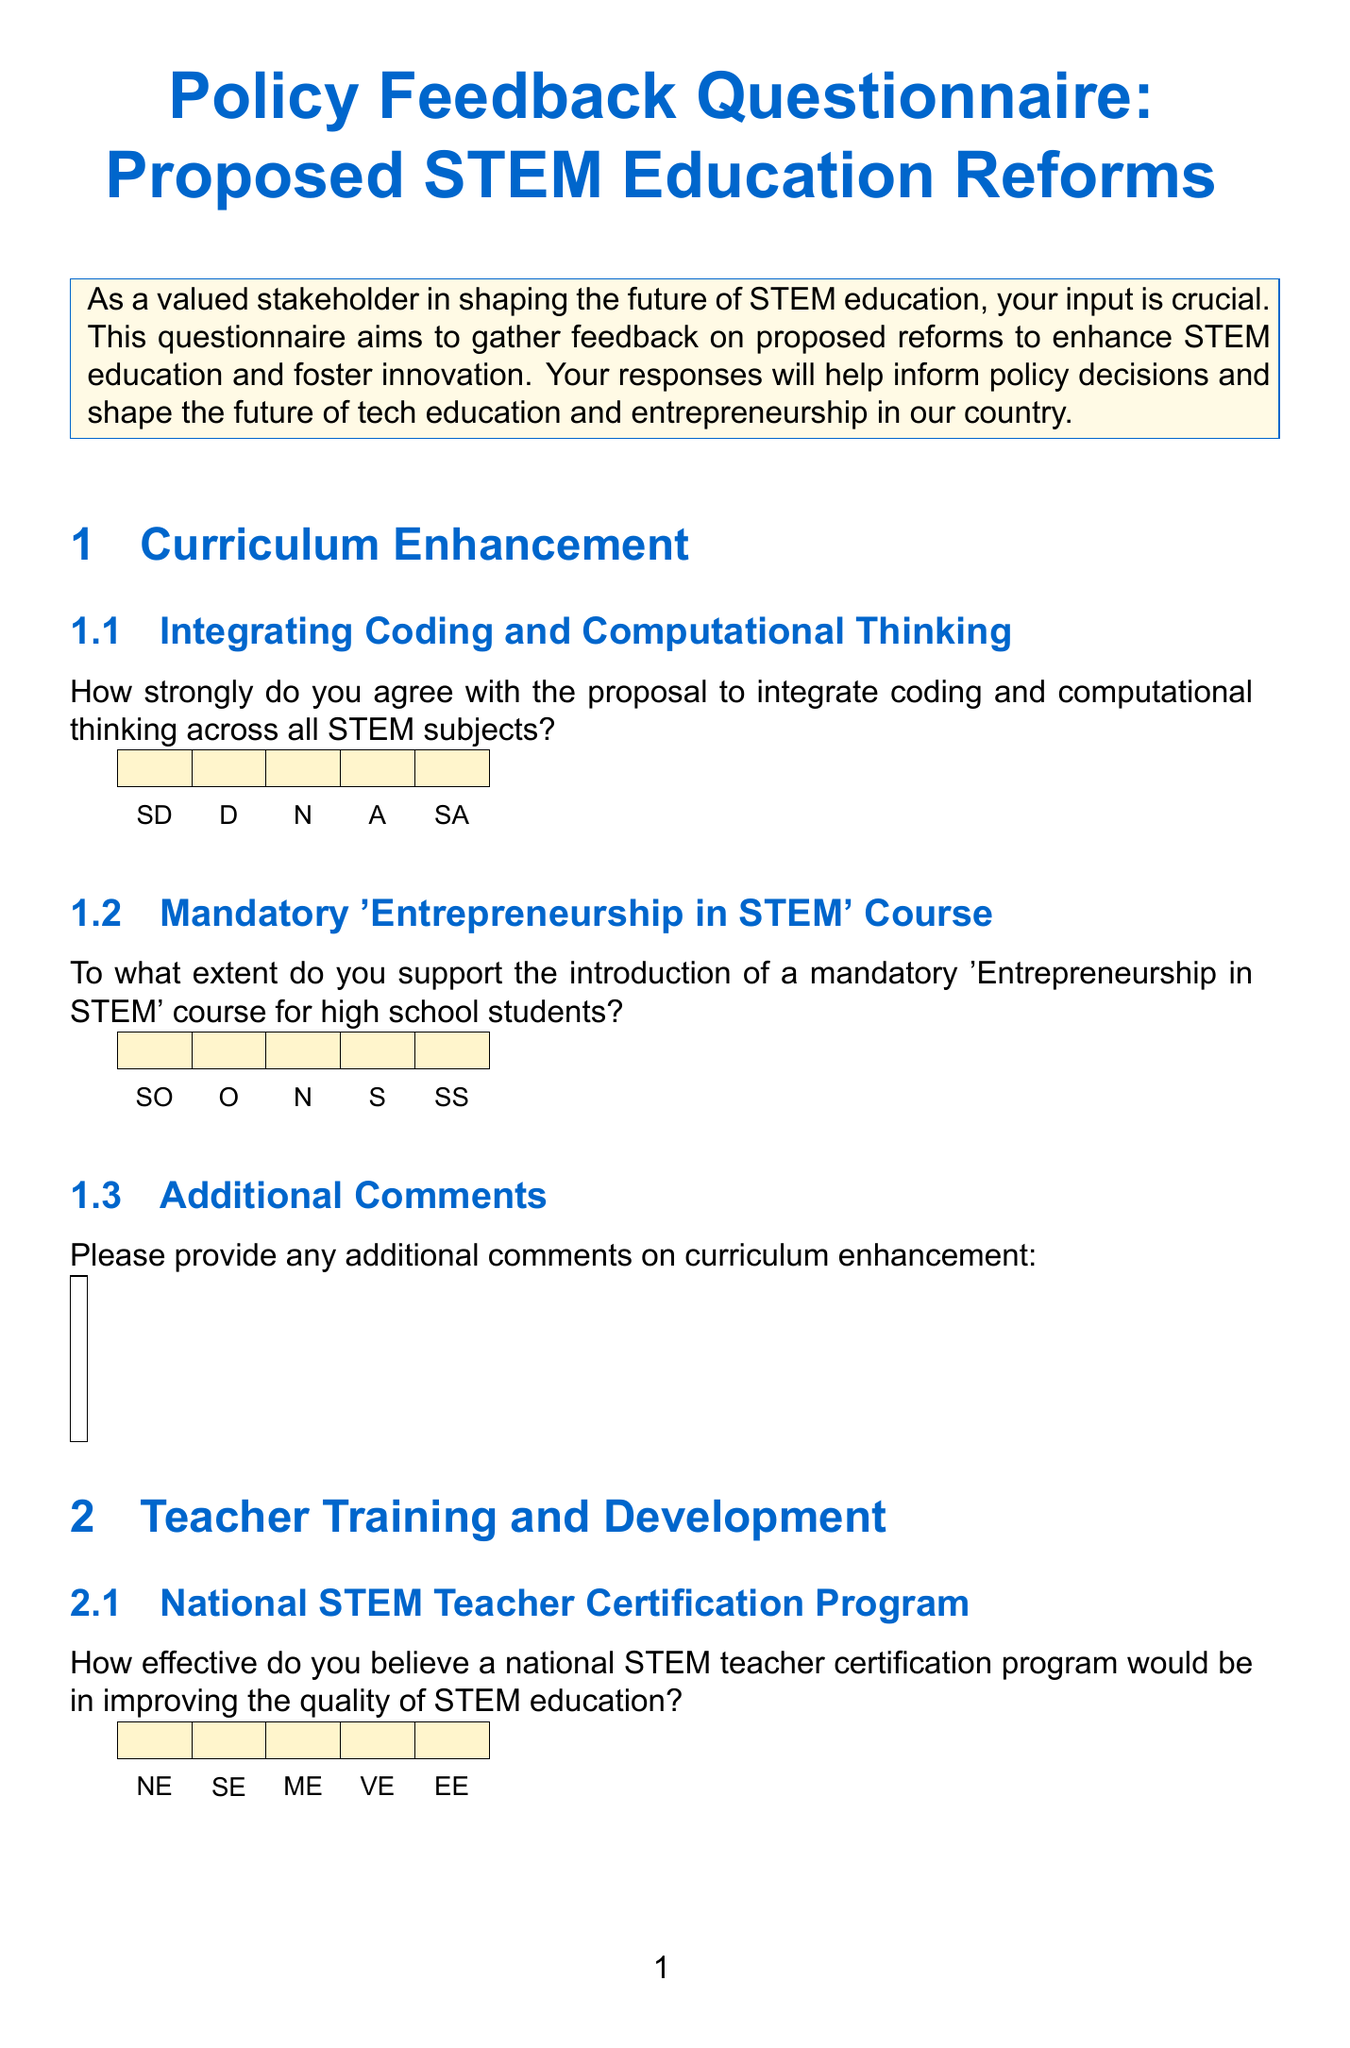What is the title of the document? The title appears at the beginning of the document in a large font.
Answer: Policy Feedback Questionnaire: Proposed STEM Education Reforms What section discusses the importance of infrastructure? The sections are outlined with specific names that denote their content focus.
Answer: Infrastructure and Resources How many Likert scale questions are in the "Teacher Training and Development" section? The number of questions can be counted directly under the specified section title.
Answer: Two What is the Likert scale option for "How effective do you believe targeted scholarships and mentorship programs would be in increasing diversity in STEM fields?" The Likert scale options provide a range of responses for questions throughout the document.
Answer: Not at all Effective What is the purpose of this questionnaire? The purpose is indicated in the introduction section of the document.
Answer: Gather feedback on proposed reforms to enhance STEM education and foster innovation How would you describe the overall format of the document? The format includes sections, questions, Likert scales, and comment boxes, which are typical in survey documents.
Answer: Questionnaire To what extent do you support the introduction of a mandatory 'Entrepreneurship in STEM' course for high school students? This question is listed in the Curriculum Enhancement section and uses a specific set of response options.
Answer: Likert scale options 